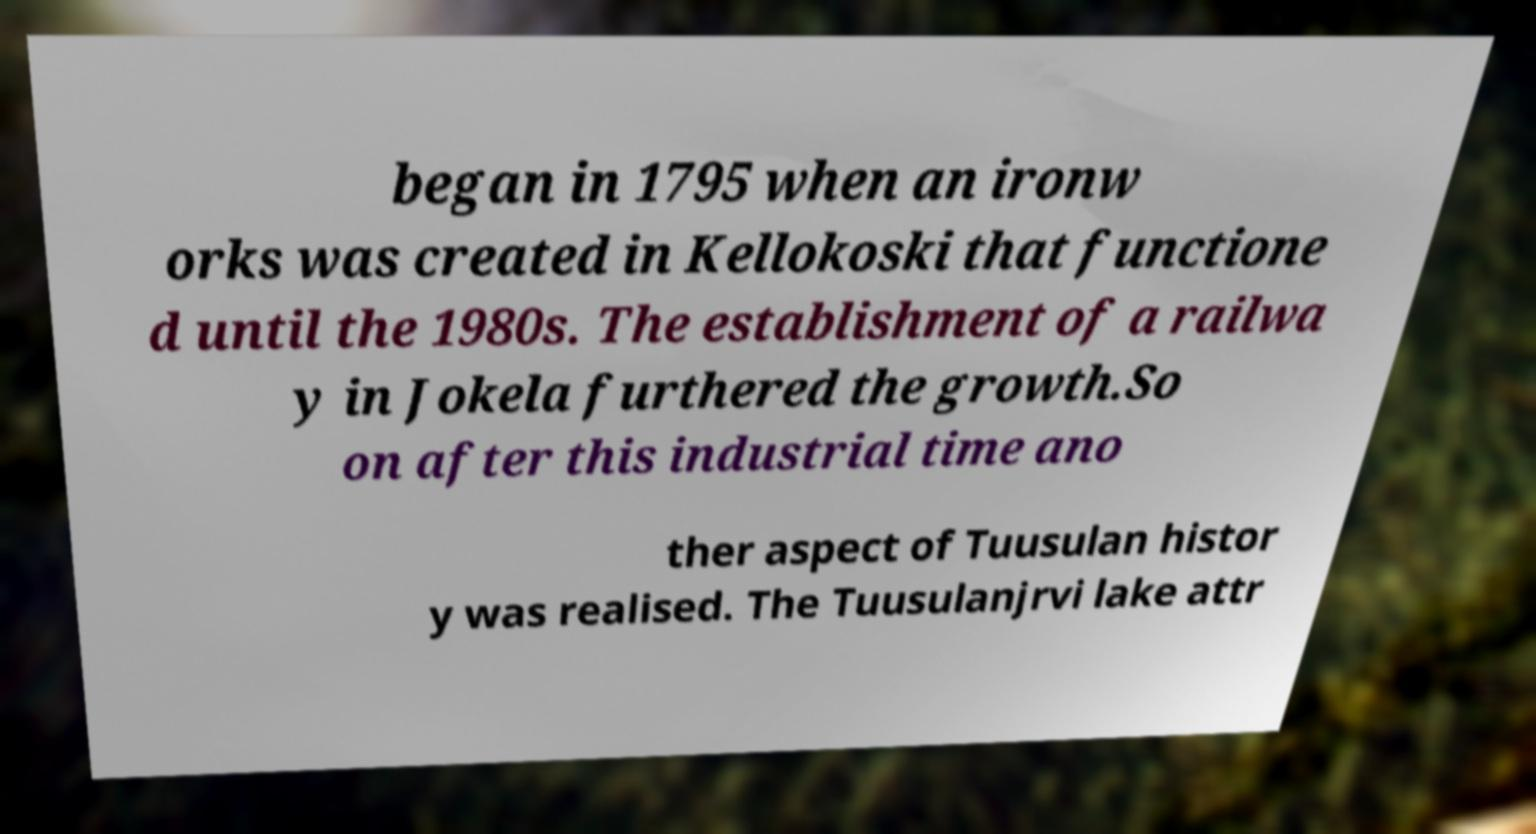What messages or text are displayed in this image? I need them in a readable, typed format. began in 1795 when an ironw orks was created in Kellokoski that functione d until the 1980s. The establishment of a railwa y in Jokela furthered the growth.So on after this industrial time ano ther aspect of Tuusulan histor y was realised. The Tuusulanjrvi lake attr 